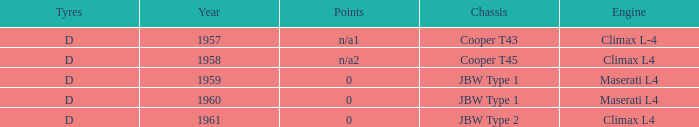What is the tyres for the JBW type 2 chassis? D. 